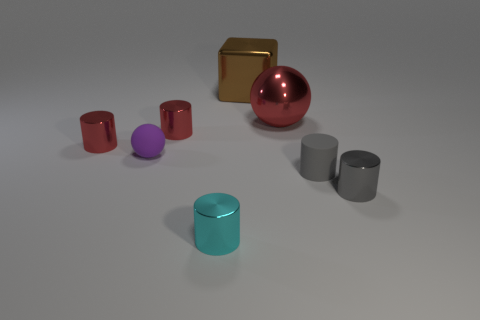Subtract all cyan cylinders. How many cylinders are left? 4 Subtract all tiny rubber cylinders. How many cylinders are left? 4 Subtract all yellow cylinders. Subtract all gray cubes. How many cylinders are left? 5 Add 1 big purple cubes. How many objects exist? 9 Subtract all balls. How many objects are left? 6 Add 8 red matte cylinders. How many red matte cylinders exist? 8 Subtract 0 brown cylinders. How many objects are left? 8 Subtract all small purple metallic things. Subtract all large metal objects. How many objects are left? 6 Add 3 cyan shiny things. How many cyan shiny things are left? 4 